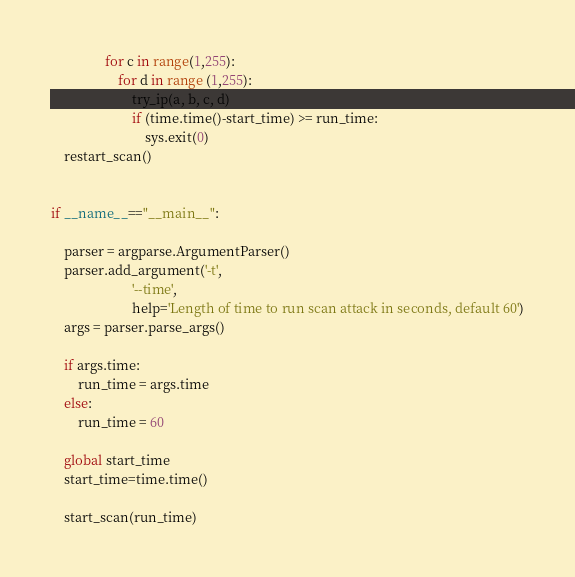<code> <loc_0><loc_0><loc_500><loc_500><_Python_>                for c in range(1,255):
                    for d in range (1,255):
                        try_ip(a, b, c, d)
                        if (time.time()-start_time) >= run_time:
                            sys.exit(0)
    restart_scan()


if __name__=="__main__":

    parser = argparse.ArgumentParser()
    parser.add_argument('-t',
                        '--time',
                        help='Length of time to run scan attack in seconds, default 60')
    args = parser.parse_args()

    if args.time:
        run_time = args.time
    else:
        run_time = 60

    global start_time
    start_time=time.time()

    start_scan(run_time)
</code> 